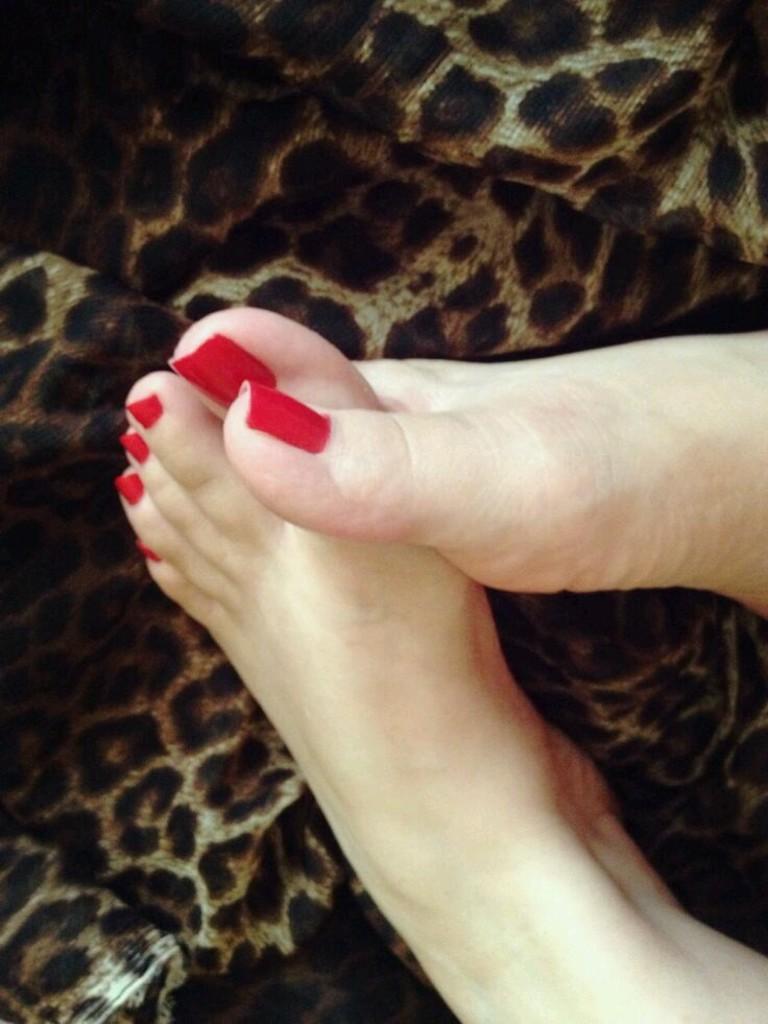How would you summarize this image in a sentence or two? As we can see in the image there are human legs and sofa. 